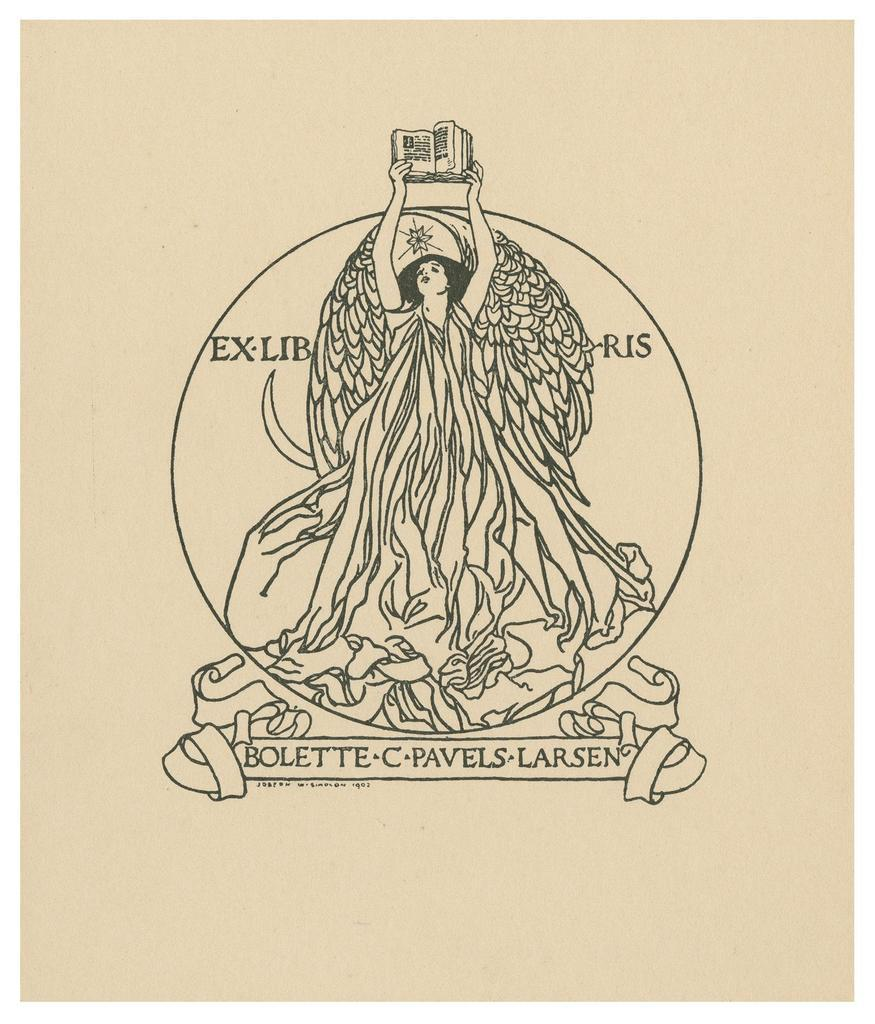What type of visual is the image in question? The image is a poster. Who or what is the main subject of the poster? There is a person depicted in the poster. What is the person holding in the poster? The person is holding a book. Are there any words or phrases on the poster? Yes, there is text written on the image. How many lines are visible on the person's face in the image? There are no visible lines on the person's face in the image, as the image is a poster and not a photograph. 